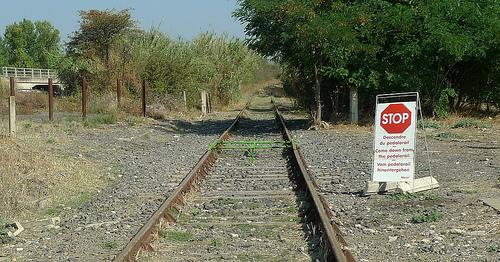How many objects are related to the train tracks in the image? At least 10 objects Identify the emotions or sentiments associated with the scene in the image. calm, serene, peaceful Which objects are interacting with each other in the image? railroad tracks, wooden ties, and stop sign What are the colors of the stop sign in the image? white and red How would you assess the image quality in terms of clear object identification? The image quality is sufficient for clear object identification. What is the main focus of the image in terms of its elements? The main focus is on the railroad tracks, stop sign, and surrounding environment. List three objects present in the image. stop sign, railroad tracks, green trees Explain the relationship between the stop sign and the railroad tracks in the image. The stop sign is placed beside the railroad tracks, warning people to stop before crossing. Provide a caption that summarizes the main features of the image. Railroad tracks surrounded by a lush green forest, with a white and red stop sign nearby. Count the number of wooden poles by the railroad tracks. There is one visible wooden pole by the railroad tracks. 